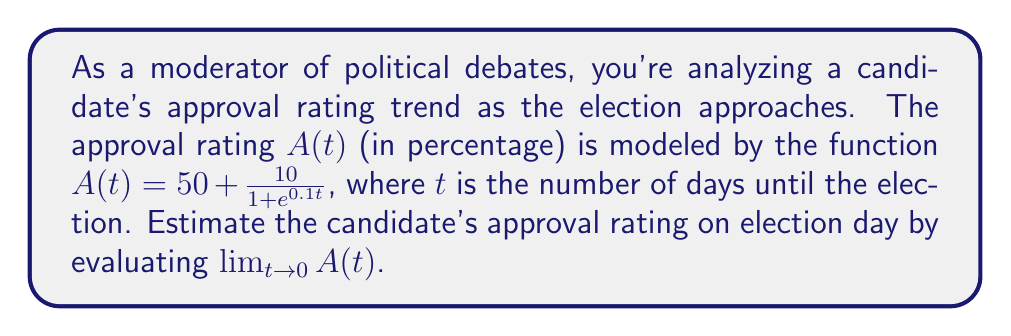Show me your answer to this math problem. To estimate the candidate's approval rating on election day, we need to evaluate the limit of $A(t)$ as $t$ approaches 0. Let's break this down step-by-step:

1) The given function is $A(t) = 50 + \frac{10}{1 + e^{0.1t}}$

2) We need to find $\lim_{t \to 0} A(t)$

3) This limit can be evaluated by direct substitution since the function is continuous at $t = 0$:

   $\lim_{t \to 0} A(t) = 50 + \lim_{t \to 0} \frac{10}{1 + e^{0.1t}}$

4) Substituting $t = 0$:

   $= 50 + \frac{10}{1 + e^{0.1(0)}}$

5) Simplify:
   
   $= 50 + \frac{10}{1 + e^0}$

6) Recall that $e^0 = 1$:

   $= 50 + \frac{10}{1 + 1}$

7) Simplify further:

   $= 50 + \frac{10}{2} = 50 + 5 = 55$

Therefore, the estimated approval rating on election day is 55%.
Answer: 55% 